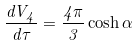<formula> <loc_0><loc_0><loc_500><loc_500>\frac { d V _ { 4 } } { d \tau } = \frac { 4 \pi } { 3 } \cosh \alpha</formula> 